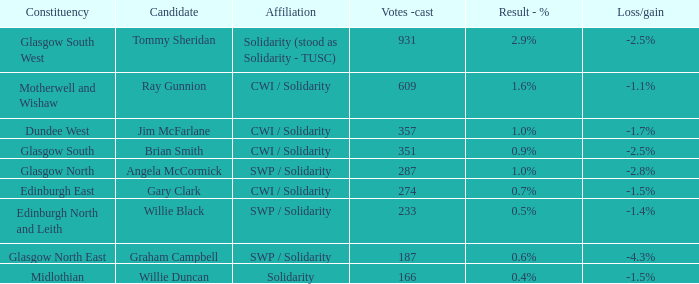When the result was 2.9%, who was the nominee? Tommy Sheridan. 